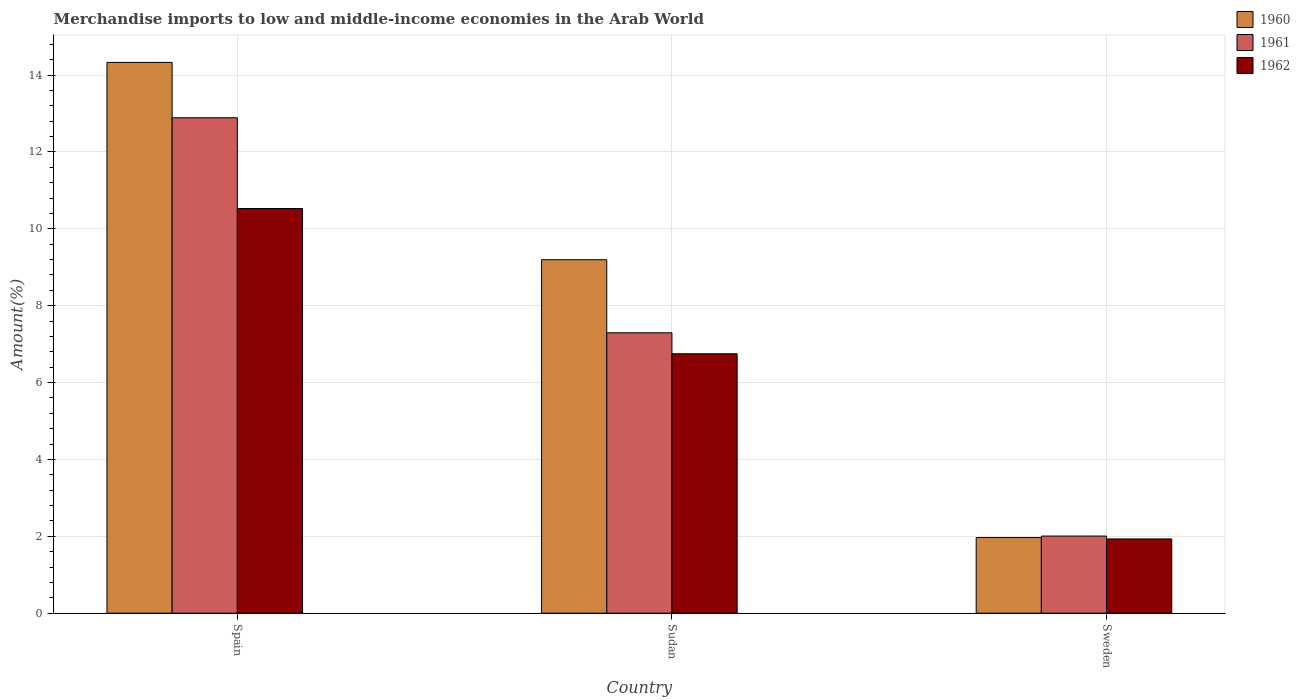How many groups of bars are there?
Make the answer very short. 3. Are the number of bars on each tick of the X-axis equal?
Keep it short and to the point. Yes. How many bars are there on the 2nd tick from the left?
Your answer should be compact. 3. How many bars are there on the 2nd tick from the right?
Ensure brevity in your answer.  3. What is the label of the 1st group of bars from the left?
Your answer should be compact. Spain. What is the percentage of amount earned from merchandise imports in 1960 in Sudan?
Your answer should be very brief. 9.2. Across all countries, what is the maximum percentage of amount earned from merchandise imports in 1961?
Your answer should be very brief. 12.89. Across all countries, what is the minimum percentage of amount earned from merchandise imports in 1960?
Keep it short and to the point. 1.97. In which country was the percentage of amount earned from merchandise imports in 1960 maximum?
Provide a short and direct response. Spain. What is the total percentage of amount earned from merchandise imports in 1960 in the graph?
Provide a short and direct response. 25.5. What is the difference between the percentage of amount earned from merchandise imports in 1962 in Sudan and that in Sweden?
Give a very brief answer. 4.82. What is the difference between the percentage of amount earned from merchandise imports in 1961 in Sweden and the percentage of amount earned from merchandise imports in 1960 in Spain?
Give a very brief answer. -12.32. What is the average percentage of amount earned from merchandise imports in 1960 per country?
Your answer should be compact. 8.5. What is the difference between the percentage of amount earned from merchandise imports of/in 1960 and percentage of amount earned from merchandise imports of/in 1961 in Sudan?
Give a very brief answer. 1.9. In how many countries, is the percentage of amount earned from merchandise imports in 1962 greater than 9.2 %?
Offer a terse response. 1. What is the ratio of the percentage of amount earned from merchandise imports in 1962 in Sudan to that in Sweden?
Give a very brief answer. 3.49. Is the difference between the percentage of amount earned from merchandise imports in 1960 in Spain and Sweden greater than the difference between the percentage of amount earned from merchandise imports in 1961 in Spain and Sweden?
Your response must be concise. Yes. What is the difference between the highest and the second highest percentage of amount earned from merchandise imports in 1960?
Your answer should be very brief. 7.23. What is the difference between the highest and the lowest percentage of amount earned from merchandise imports in 1961?
Offer a very short reply. 10.88. Is the sum of the percentage of amount earned from merchandise imports in 1961 in Spain and Sweden greater than the maximum percentage of amount earned from merchandise imports in 1960 across all countries?
Your response must be concise. Yes. Is it the case that in every country, the sum of the percentage of amount earned from merchandise imports in 1962 and percentage of amount earned from merchandise imports in 1960 is greater than the percentage of amount earned from merchandise imports in 1961?
Your response must be concise. Yes. Are all the bars in the graph horizontal?
Offer a very short reply. No. Does the graph contain grids?
Your answer should be very brief. Yes. How many legend labels are there?
Offer a terse response. 3. What is the title of the graph?
Your answer should be compact. Merchandise imports to low and middle-income economies in the Arab World. Does "1961" appear as one of the legend labels in the graph?
Provide a succinct answer. Yes. What is the label or title of the Y-axis?
Ensure brevity in your answer.  Amount(%). What is the Amount(%) in 1960 in Spain?
Your response must be concise. 14.33. What is the Amount(%) of 1961 in Spain?
Your answer should be very brief. 12.89. What is the Amount(%) of 1962 in Spain?
Offer a very short reply. 10.53. What is the Amount(%) in 1960 in Sudan?
Your answer should be compact. 9.2. What is the Amount(%) of 1961 in Sudan?
Provide a short and direct response. 7.3. What is the Amount(%) in 1962 in Sudan?
Offer a very short reply. 6.75. What is the Amount(%) of 1960 in Sweden?
Your answer should be compact. 1.97. What is the Amount(%) in 1961 in Sweden?
Provide a short and direct response. 2.01. What is the Amount(%) of 1962 in Sweden?
Provide a succinct answer. 1.93. Across all countries, what is the maximum Amount(%) of 1960?
Your answer should be compact. 14.33. Across all countries, what is the maximum Amount(%) of 1961?
Provide a short and direct response. 12.89. Across all countries, what is the maximum Amount(%) in 1962?
Keep it short and to the point. 10.53. Across all countries, what is the minimum Amount(%) in 1960?
Offer a terse response. 1.97. Across all countries, what is the minimum Amount(%) in 1961?
Provide a short and direct response. 2.01. Across all countries, what is the minimum Amount(%) in 1962?
Provide a succinct answer. 1.93. What is the total Amount(%) in 1960 in the graph?
Your answer should be compact. 25.5. What is the total Amount(%) in 1961 in the graph?
Your answer should be compact. 22.19. What is the total Amount(%) in 1962 in the graph?
Your response must be concise. 19.21. What is the difference between the Amount(%) in 1960 in Spain and that in Sudan?
Provide a succinct answer. 5.13. What is the difference between the Amount(%) in 1961 in Spain and that in Sudan?
Your answer should be very brief. 5.59. What is the difference between the Amount(%) of 1962 in Spain and that in Sudan?
Ensure brevity in your answer.  3.78. What is the difference between the Amount(%) of 1960 in Spain and that in Sweden?
Your answer should be compact. 12.36. What is the difference between the Amount(%) in 1961 in Spain and that in Sweden?
Provide a succinct answer. 10.88. What is the difference between the Amount(%) in 1962 in Spain and that in Sweden?
Your answer should be very brief. 8.6. What is the difference between the Amount(%) of 1960 in Sudan and that in Sweden?
Offer a very short reply. 7.23. What is the difference between the Amount(%) in 1961 in Sudan and that in Sweden?
Offer a terse response. 5.29. What is the difference between the Amount(%) of 1962 in Sudan and that in Sweden?
Your answer should be compact. 4.82. What is the difference between the Amount(%) of 1960 in Spain and the Amount(%) of 1961 in Sudan?
Keep it short and to the point. 7.03. What is the difference between the Amount(%) of 1960 in Spain and the Amount(%) of 1962 in Sudan?
Keep it short and to the point. 7.58. What is the difference between the Amount(%) in 1961 in Spain and the Amount(%) in 1962 in Sudan?
Offer a very short reply. 6.14. What is the difference between the Amount(%) of 1960 in Spain and the Amount(%) of 1961 in Sweden?
Ensure brevity in your answer.  12.32. What is the difference between the Amount(%) of 1960 in Spain and the Amount(%) of 1962 in Sweden?
Give a very brief answer. 12.4. What is the difference between the Amount(%) in 1961 in Spain and the Amount(%) in 1962 in Sweden?
Your answer should be compact. 10.96. What is the difference between the Amount(%) of 1960 in Sudan and the Amount(%) of 1961 in Sweden?
Your response must be concise. 7.19. What is the difference between the Amount(%) of 1960 in Sudan and the Amount(%) of 1962 in Sweden?
Give a very brief answer. 7.26. What is the difference between the Amount(%) in 1961 in Sudan and the Amount(%) in 1962 in Sweden?
Give a very brief answer. 5.36. What is the average Amount(%) in 1960 per country?
Offer a very short reply. 8.5. What is the average Amount(%) in 1961 per country?
Your answer should be very brief. 7.4. What is the average Amount(%) in 1962 per country?
Your response must be concise. 6.4. What is the difference between the Amount(%) in 1960 and Amount(%) in 1961 in Spain?
Provide a succinct answer. 1.44. What is the difference between the Amount(%) in 1960 and Amount(%) in 1962 in Spain?
Ensure brevity in your answer.  3.8. What is the difference between the Amount(%) of 1961 and Amount(%) of 1962 in Spain?
Provide a succinct answer. 2.36. What is the difference between the Amount(%) in 1960 and Amount(%) in 1961 in Sudan?
Provide a succinct answer. 1.9. What is the difference between the Amount(%) of 1960 and Amount(%) of 1962 in Sudan?
Your answer should be compact. 2.45. What is the difference between the Amount(%) in 1961 and Amount(%) in 1962 in Sudan?
Ensure brevity in your answer.  0.55. What is the difference between the Amount(%) in 1960 and Amount(%) in 1961 in Sweden?
Offer a very short reply. -0.04. What is the difference between the Amount(%) of 1960 and Amount(%) of 1962 in Sweden?
Give a very brief answer. 0.04. What is the difference between the Amount(%) in 1961 and Amount(%) in 1962 in Sweden?
Keep it short and to the point. 0.07. What is the ratio of the Amount(%) of 1960 in Spain to that in Sudan?
Ensure brevity in your answer.  1.56. What is the ratio of the Amount(%) in 1961 in Spain to that in Sudan?
Offer a terse response. 1.77. What is the ratio of the Amount(%) in 1962 in Spain to that in Sudan?
Your response must be concise. 1.56. What is the ratio of the Amount(%) in 1960 in Spain to that in Sweden?
Ensure brevity in your answer.  7.28. What is the ratio of the Amount(%) in 1961 in Spain to that in Sweden?
Offer a terse response. 6.42. What is the ratio of the Amount(%) in 1962 in Spain to that in Sweden?
Offer a very short reply. 5.45. What is the ratio of the Amount(%) of 1960 in Sudan to that in Sweden?
Offer a terse response. 4.67. What is the ratio of the Amount(%) of 1961 in Sudan to that in Sweden?
Give a very brief answer. 3.63. What is the ratio of the Amount(%) of 1962 in Sudan to that in Sweden?
Make the answer very short. 3.49. What is the difference between the highest and the second highest Amount(%) in 1960?
Make the answer very short. 5.13. What is the difference between the highest and the second highest Amount(%) in 1961?
Your answer should be very brief. 5.59. What is the difference between the highest and the second highest Amount(%) in 1962?
Your response must be concise. 3.78. What is the difference between the highest and the lowest Amount(%) in 1960?
Offer a very short reply. 12.36. What is the difference between the highest and the lowest Amount(%) of 1961?
Your answer should be very brief. 10.88. What is the difference between the highest and the lowest Amount(%) of 1962?
Provide a succinct answer. 8.6. 